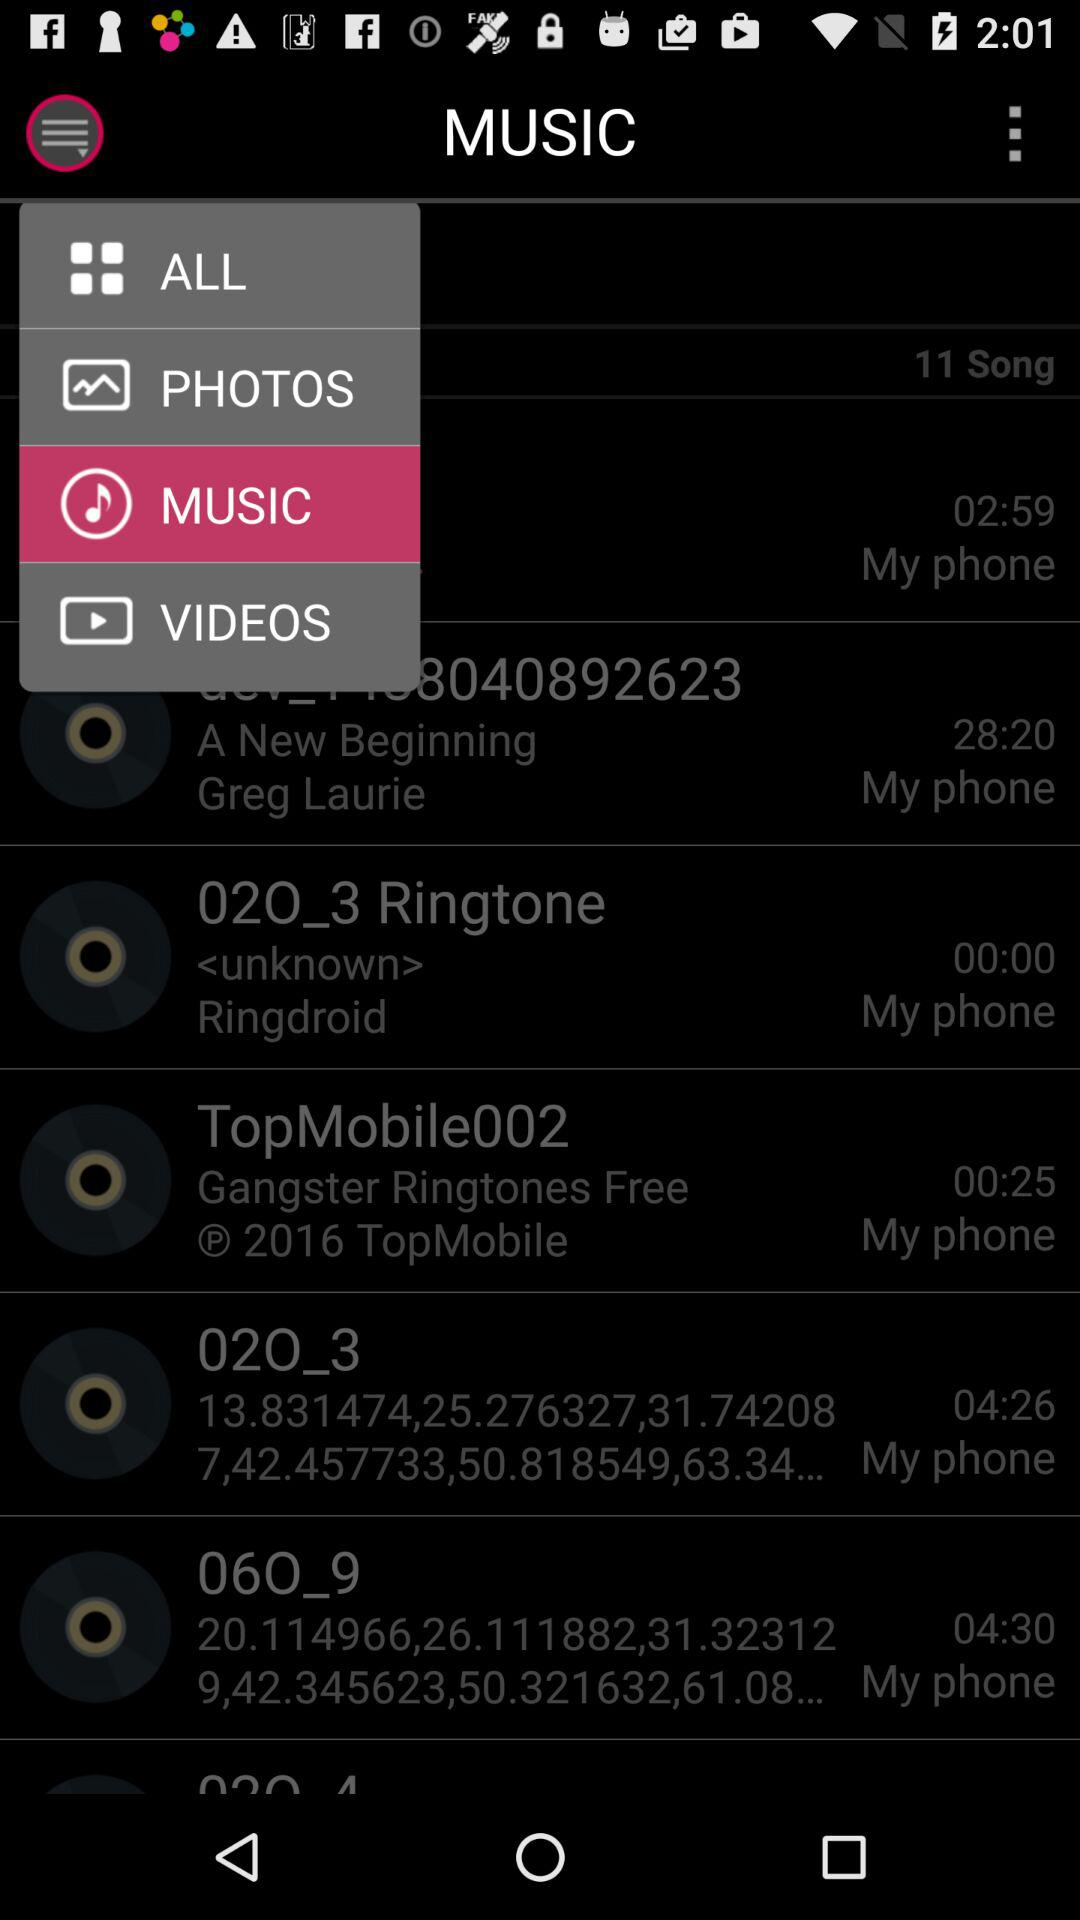Which option is selected? The selected option is "MUSIC". 